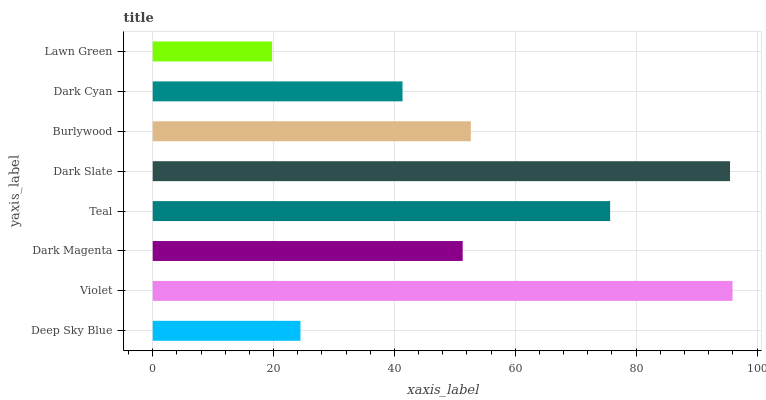Is Lawn Green the minimum?
Answer yes or no. Yes. Is Violet the maximum?
Answer yes or no. Yes. Is Dark Magenta the minimum?
Answer yes or no. No. Is Dark Magenta the maximum?
Answer yes or no. No. Is Violet greater than Dark Magenta?
Answer yes or no. Yes. Is Dark Magenta less than Violet?
Answer yes or no. Yes. Is Dark Magenta greater than Violet?
Answer yes or no. No. Is Violet less than Dark Magenta?
Answer yes or no. No. Is Burlywood the high median?
Answer yes or no. Yes. Is Dark Magenta the low median?
Answer yes or no. Yes. Is Dark Magenta the high median?
Answer yes or no. No. Is Dark Slate the low median?
Answer yes or no. No. 